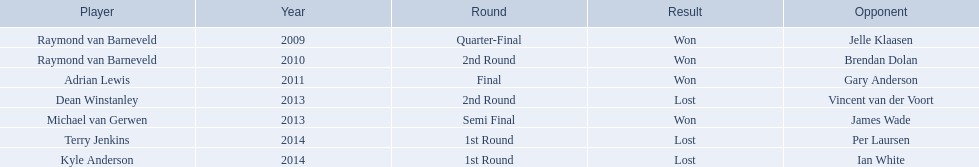Who are the players included in the list? Raymond van Barneveld, Raymond van Barneveld, Adrian Lewis, Dean Winstanley, Michael van Gerwen, Terry Jenkins, Kyle Anderson. Which ones had played in the year 2011? Adrian Lewis. 